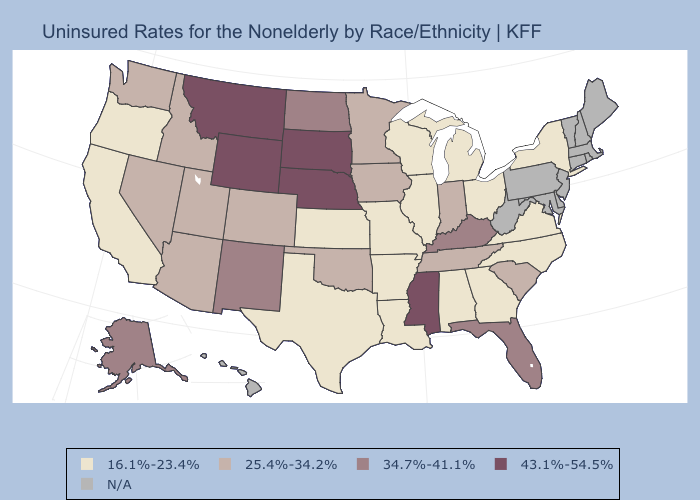What is the value of Nevada?
Answer briefly. 25.4%-34.2%. Is the legend a continuous bar?
Short answer required. No. Name the states that have a value in the range 43.1%-54.5%?
Concise answer only. Mississippi, Montana, Nebraska, South Dakota, Wyoming. Does the map have missing data?
Write a very short answer. Yes. What is the highest value in the South ?
Concise answer only. 43.1%-54.5%. Does New Mexico have the lowest value in the West?
Short answer required. No. Name the states that have a value in the range 34.7%-41.1%?
Concise answer only. Alaska, Florida, Kentucky, New Mexico, North Dakota. What is the value of Pennsylvania?
Short answer required. N/A. What is the value of New Hampshire?
Be succinct. N/A. Among the states that border Massachusetts , which have the highest value?
Give a very brief answer. New York. What is the value of New York?
Write a very short answer. 16.1%-23.4%. Among the states that border Colorado , which have the highest value?
Keep it brief. Nebraska, Wyoming. What is the value of Ohio?
Be succinct. 16.1%-23.4%. Does Wyoming have the highest value in the USA?
Keep it brief. Yes. What is the value of Illinois?
Quick response, please. 16.1%-23.4%. 